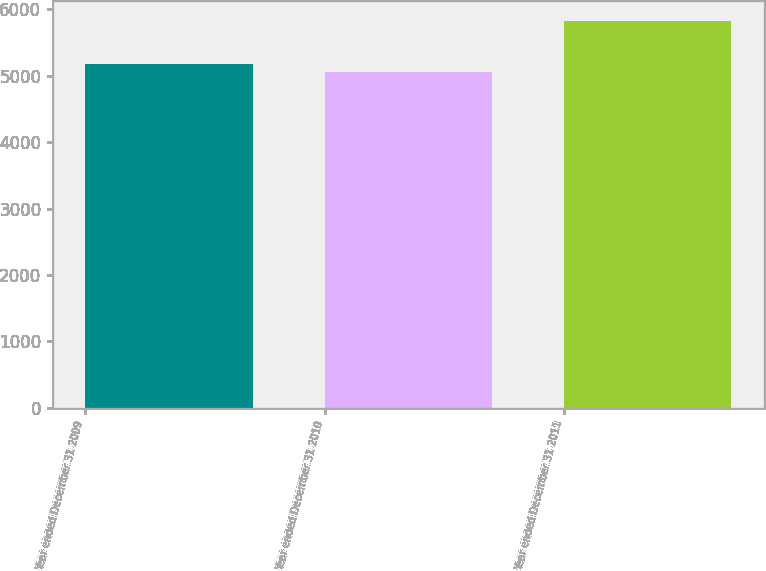<chart> <loc_0><loc_0><loc_500><loc_500><bar_chart><fcel>Year ended December 31 2009<fcel>Year ended December 31 2010<fcel>Year ended December 31 2011<nl><fcel>5183<fcel>5063<fcel>5831<nl></chart> 